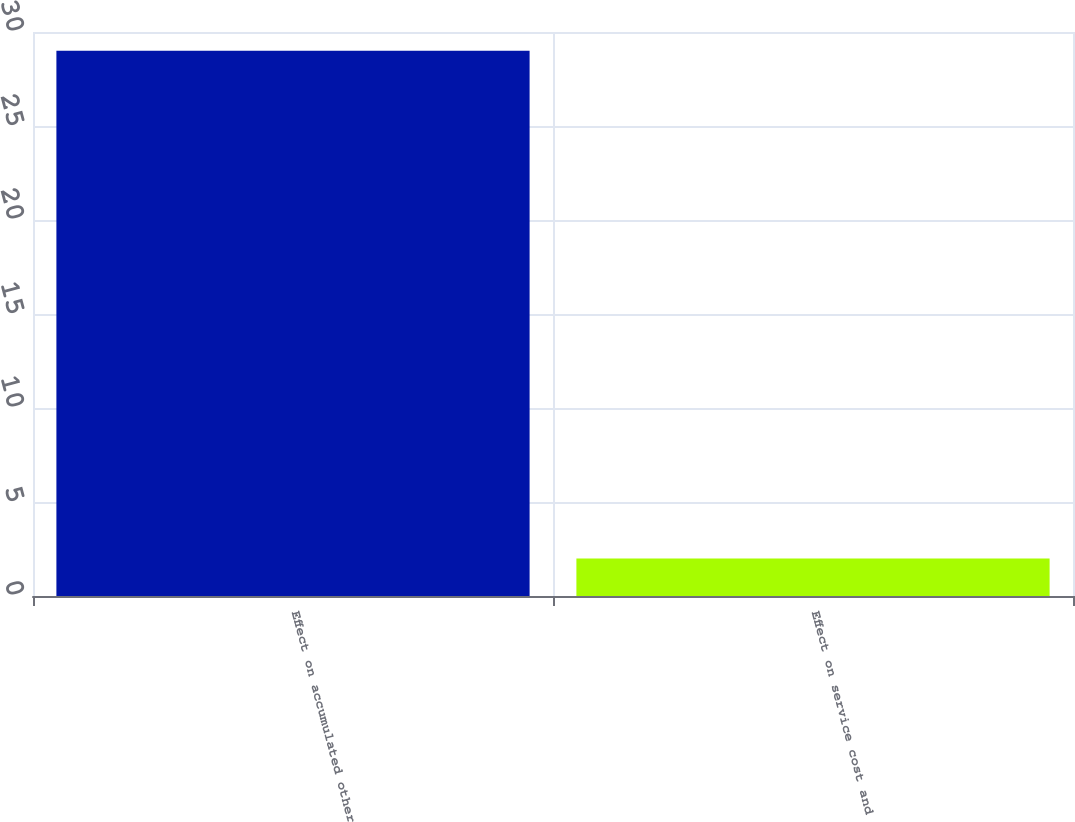Convert chart to OTSL. <chart><loc_0><loc_0><loc_500><loc_500><bar_chart><fcel>Effect on accumulated other<fcel>Effect on service cost and<nl><fcel>29<fcel>2<nl></chart> 